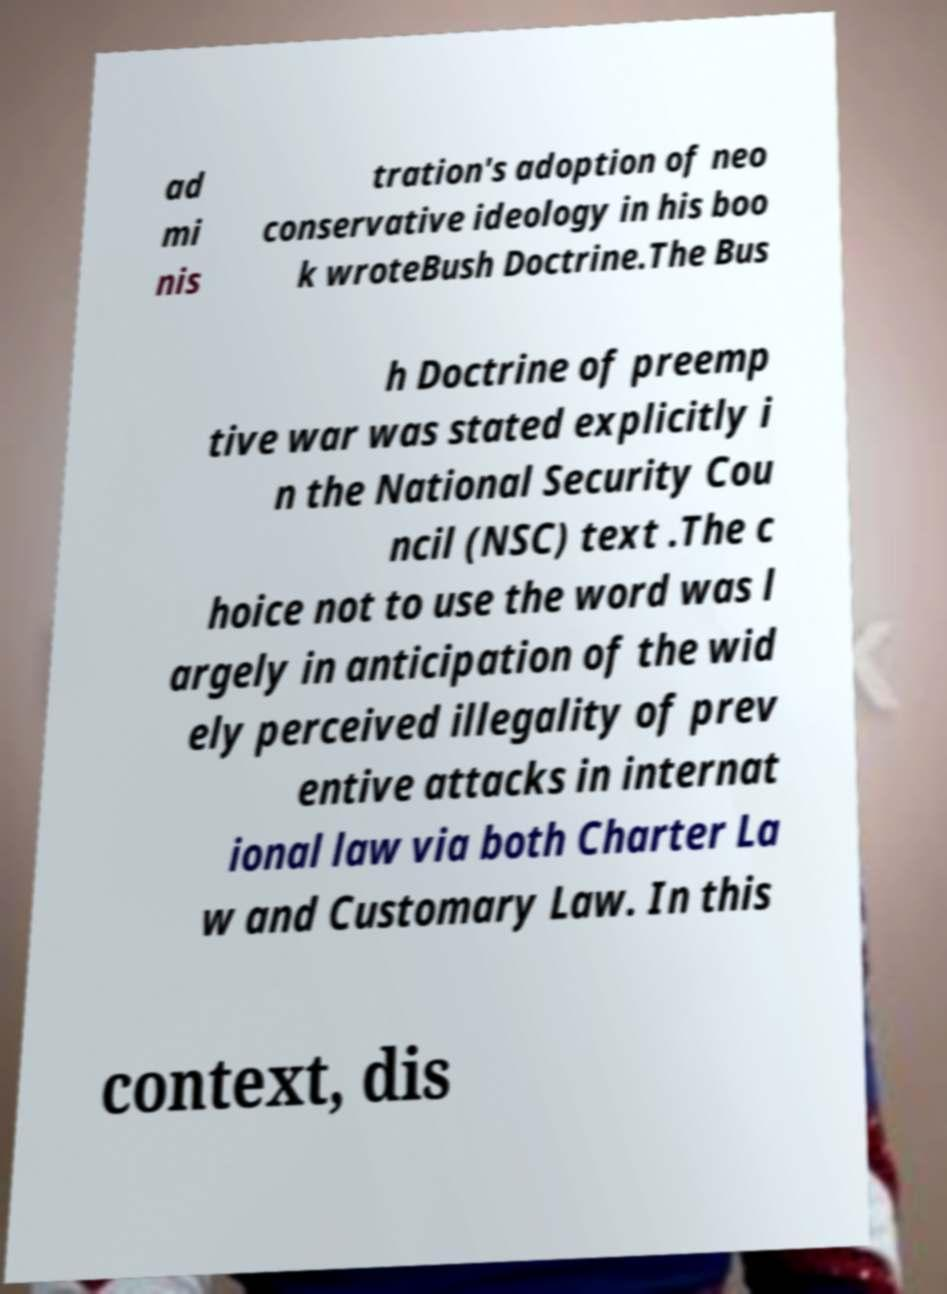Could you assist in decoding the text presented in this image and type it out clearly? ad mi nis tration's adoption of neo conservative ideology in his boo k wroteBush Doctrine.The Bus h Doctrine of preemp tive war was stated explicitly i n the National Security Cou ncil (NSC) text .The c hoice not to use the word was l argely in anticipation of the wid ely perceived illegality of prev entive attacks in internat ional law via both Charter La w and Customary Law. In this context, dis 